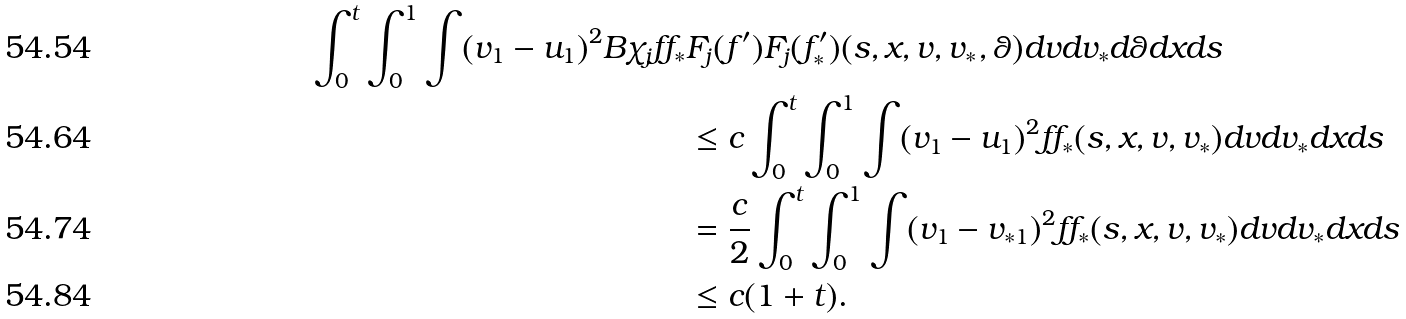Convert formula to latex. <formula><loc_0><loc_0><loc_500><loc_500>\int _ { 0 } ^ { t } \int _ { 0 } ^ { 1 } \int ( v _ { 1 } - u _ { 1 } ) ^ { 2 } B { \chi } _ { j } f f _ { * } & F _ { j } ( f ^ { \prime } ) F _ { j } ( f ^ { \prime } _ { * } ) ( s , x , v , v _ { * } , \theta ) d v d v _ { * } d \theta d x d s \\ & \leq c \int _ { 0 } ^ { t } \int _ { 0 } ^ { 1 } \int ( v _ { 1 } - u _ { 1 } ) ^ { 2 } f f _ { * } ( s , x , v , v _ { * } ) d v d v _ { * } d x d s \\ & = \frac { c } { 2 } \int _ { 0 } ^ { t } \int _ { 0 } ^ { 1 } \int ( v _ { 1 } - v _ { * 1 } ) ^ { 2 } f f _ { * } ( s , x , v , v _ { * } ) d v d v _ { * } d x d s \\ & \leq c ( 1 + t ) .</formula> 